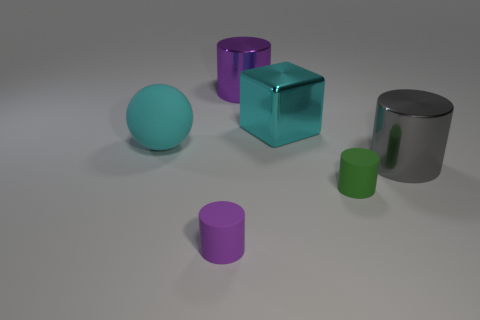Subtract all small green cylinders. How many cylinders are left? 3 Subtract all purple cylinders. How many cylinders are left? 2 Add 3 small gray rubber cylinders. How many objects exist? 9 Subtract 0 green cubes. How many objects are left? 6 Subtract all cubes. How many objects are left? 5 Subtract all green blocks. Subtract all brown cylinders. How many blocks are left? 1 Subtract all gray blocks. How many red cylinders are left? 0 Subtract all big purple objects. Subtract all purple shiny objects. How many objects are left? 4 Add 4 gray cylinders. How many gray cylinders are left? 5 Add 4 large cylinders. How many large cylinders exist? 6 